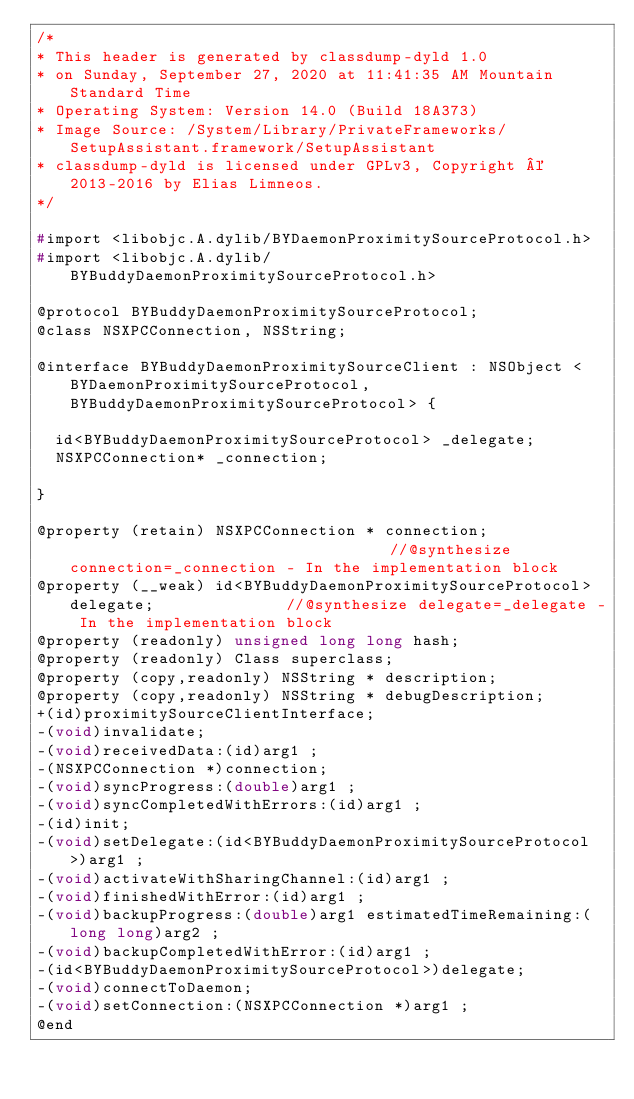<code> <loc_0><loc_0><loc_500><loc_500><_C_>/*
* This header is generated by classdump-dyld 1.0
* on Sunday, September 27, 2020 at 11:41:35 AM Mountain Standard Time
* Operating System: Version 14.0 (Build 18A373)
* Image Source: /System/Library/PrivateFrameworks/SetupAssistant.framework/SetupAssistant
* classdump-dyld is licensed under GPLv3, Copyright © 2013-2016 by Elias Limneos.
*/

#import <libobjc.A.dylib/BYDaemonProximitySourceProtocol.h>
#import <libobjc.A.dylib/BYBuddyDaemonProximitySourceProtocol.h>

@protocol BYBuddyDaemonProximitySourceProtocol;
@class NSXPCConnection, NSString;

@interface BYBuddyDaemonProximitySourceClient : NSObject <BYDaemonProximitySourceProtocol, BYBuddyDaemonProximitySourceProtocol> {

	id<BYBuddyDaemonProximitySourceProtocol> _delegate;
	NSXPCConnection* _connection;

}

@property (retain) NSXPCConnection * connection;                                   //@synthesize connection=_connection - In the implementation block
@property (__weak) id<BYBuddyDaemonProximitySourceProtocol> delegate;              //@synthesize delegate=_delegate - In the implementation block
@property (readonly) unsigned long long hash; 
@property (readonly) Class superclass; 
@property (copy,readonly) NSString * description; 
@property (copy,readonly) NSString * debugDescription; 
+(id)proximitySourceClientInterface;
-(void)invalidate;
-(void)receivedData:(id)arg1 ;
-(NSXPCConnection *)connection;
-(void)syncProgress:(double)arg1 ;
-(void)syncCompletedWithErrors:(id)arg1 ;
-(id)init;
-(void)setDelegate:(id<BYBuddyDaemonProximitySourceProtocol>)arg1 ;
-(void)activateWithSharingChannel:(id)arg1 ;
-(void)finishedWithError:(id)arg1 ;
-(void)backupProgress:(double)arg1 estimatedTimeRemaining:(long long)arg2 ;
-(void)backupCompletedWithError:(id)arg1 ;
-(id<BYBuddyDaemonProximitySourceProtocol>)delegate;
-(void)connectToDaemon;
-(void)setConnection:(NSXPCConnection *)arg1 ;
@end

</code> 